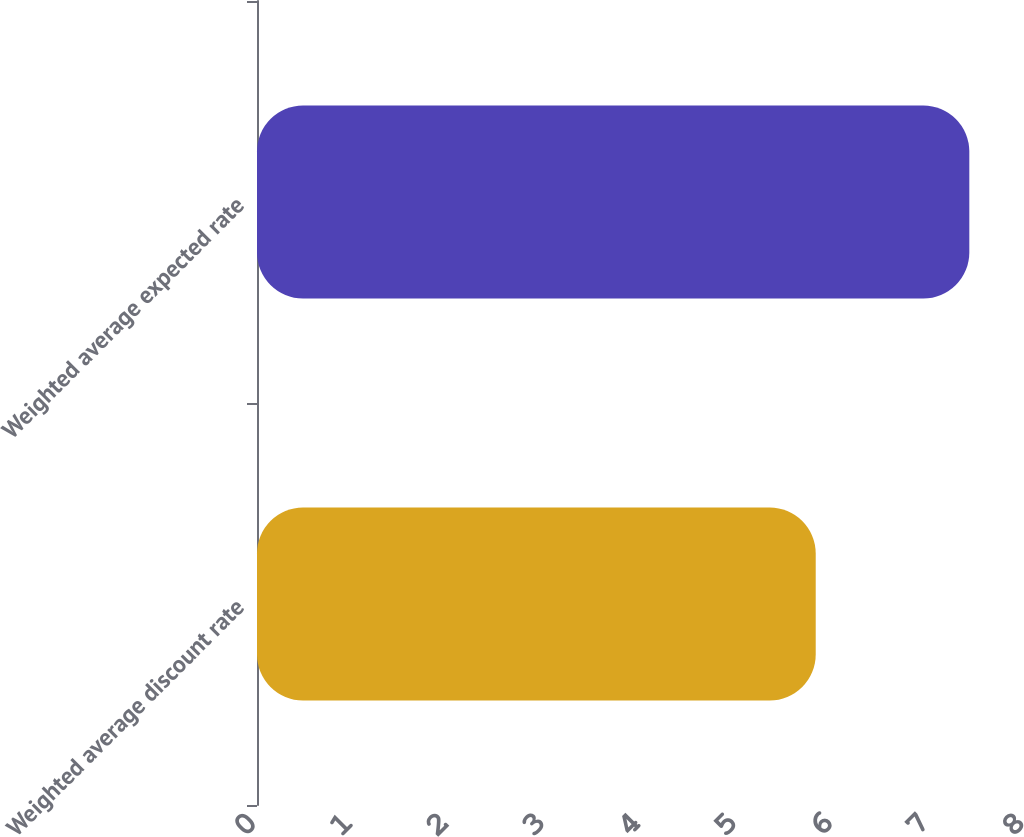Convert chart. <chart><loc_0><loc_0><loc_500><loc_500><bar_chart><fcel>Weighted average discount rate<fcel>Weighted average expected rate<nl><fcel>5.82<fcel>7.42<nl></chart> 